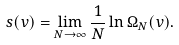Convert formula to latex. <formula><loc_0><loc_0><loc_500><loc_500>s ( v ) = \lim _ { N \to \infty } \frac { 1 } { N } \ln \Omega _ { N } ( v ) .</formula> 